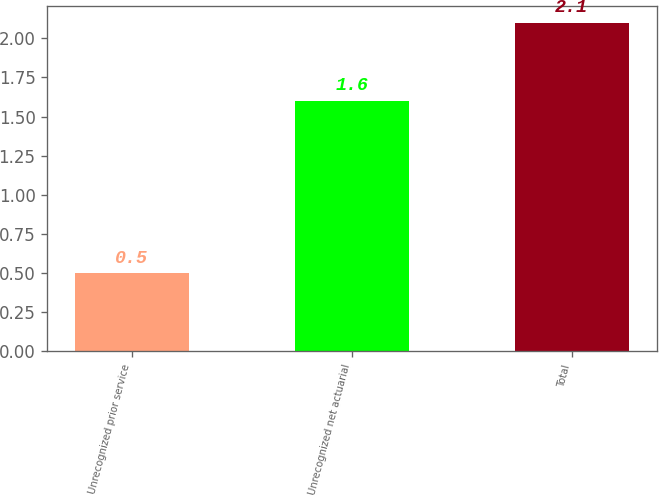Convert chart. <chart><loc_0><loc_0><loc_500><loc_500><bar_chart><fcel>Unrecognized prior service<fcel>Unrecognized net actuarial<fcel>Total<nl><fcel>0.5<fcel>1.6<fcel>2.1<nl></chart> 